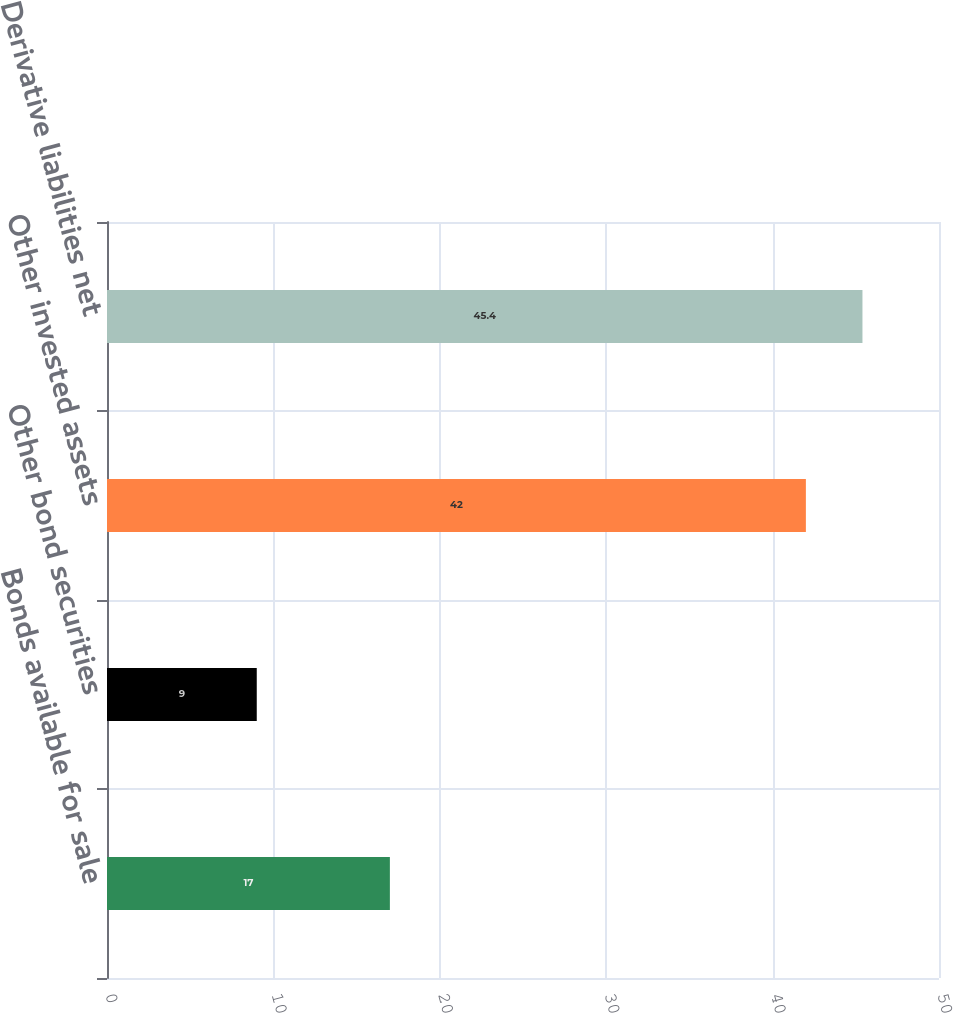<chart> <loc_0><loc_0><loc_500><loc_500><bar_chart><fcel>Bonds available for sale<fcel>Other bond securities<fcel>Other invested assets<fcel>Derivative liabilities net<nl><fcel>17<fcel>9<fcel>42<fcel>45.4<nl></chart> 